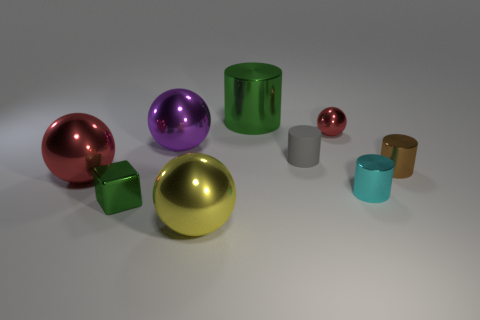What size is the cylinder that is the same color as the cube?
Make the answer very short. Large. How many other large shiny cylinders are the same color as the large cylinder?
Keep it short and to the point. 0. The big green thing has what shape?
Offer a very short reply. Cylinder. What is the color of the tiny shiny object that is in front of the big red ball and to the right of the small green cube?
Your answer should be compact. Cyan. What is the material of the large green thing?
Offer a very short reply. Metal. What shape is the red shiny object in front of the small sphere?
Make the answer very short. Sphere. The metallic cylinder that is the same size as the yellow metallic thing is what color?
Offer a terse response. Green. Is the material of the red object to the left of the green metal cylinder the same as the small green object?
Offer a very short reply. Yes. There is a sphere that is behind the brown metal thing and left of the green cylinder; what size is it?
Your answer should be compact. Large. How big is the red metal thing on the right side of the big yellow metallic object?
Provide a succinct answer. Small. 